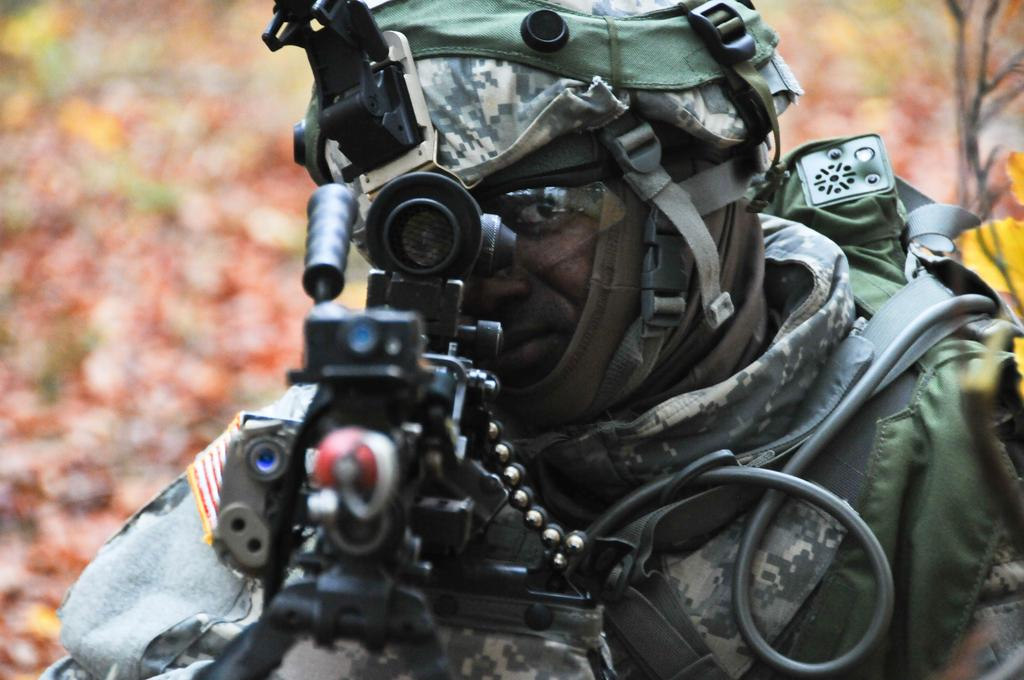What is the main subject of the image? There is a person in the image. What object is present with the person? There is a gun in the image. Are there any additional items related to the gun? Yes, there are bullets in the image. How would you describe the background of the image? The background of the image is blurry. What is the size of the seat in the image? There is no seat present in the image. What year does the image depict? The image does not depict a specific year. 